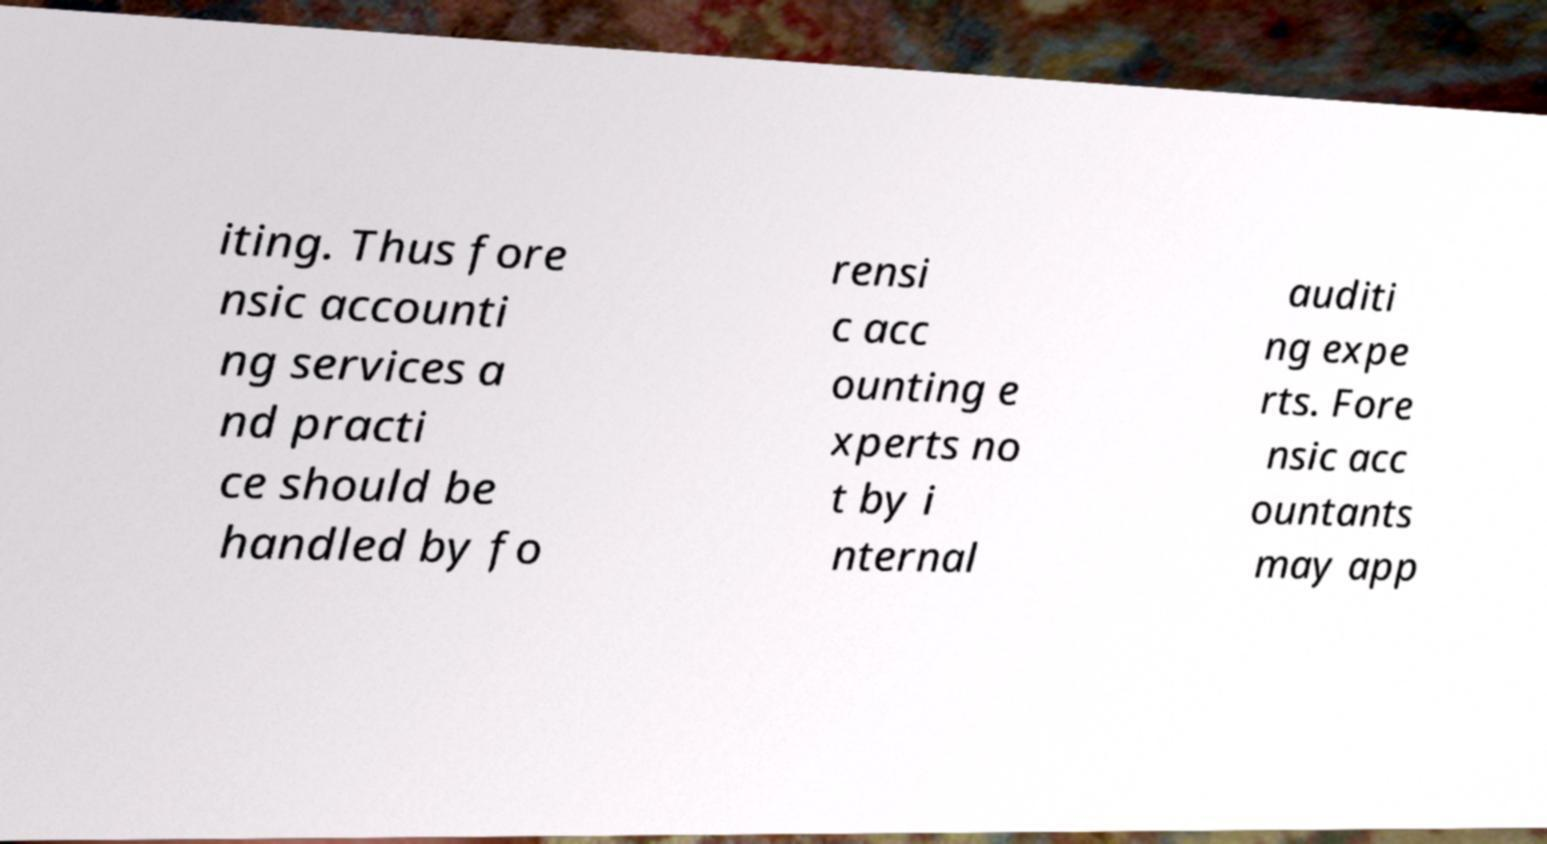I need the written content from this picture converted into text. Can you do that? iting. Thus fore nsic accounti ng services a nd practi ce should be handled by fo rensi c acc ounting e xperts no t by i nternal auditi ng expe rts. Fore nsic acc ountants may app 